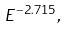Convert formula to latex. <formula><loc_0><loc_0><loc_500><loc_500>E ^ { - 2 . 7 1 5 } ,</formula> 